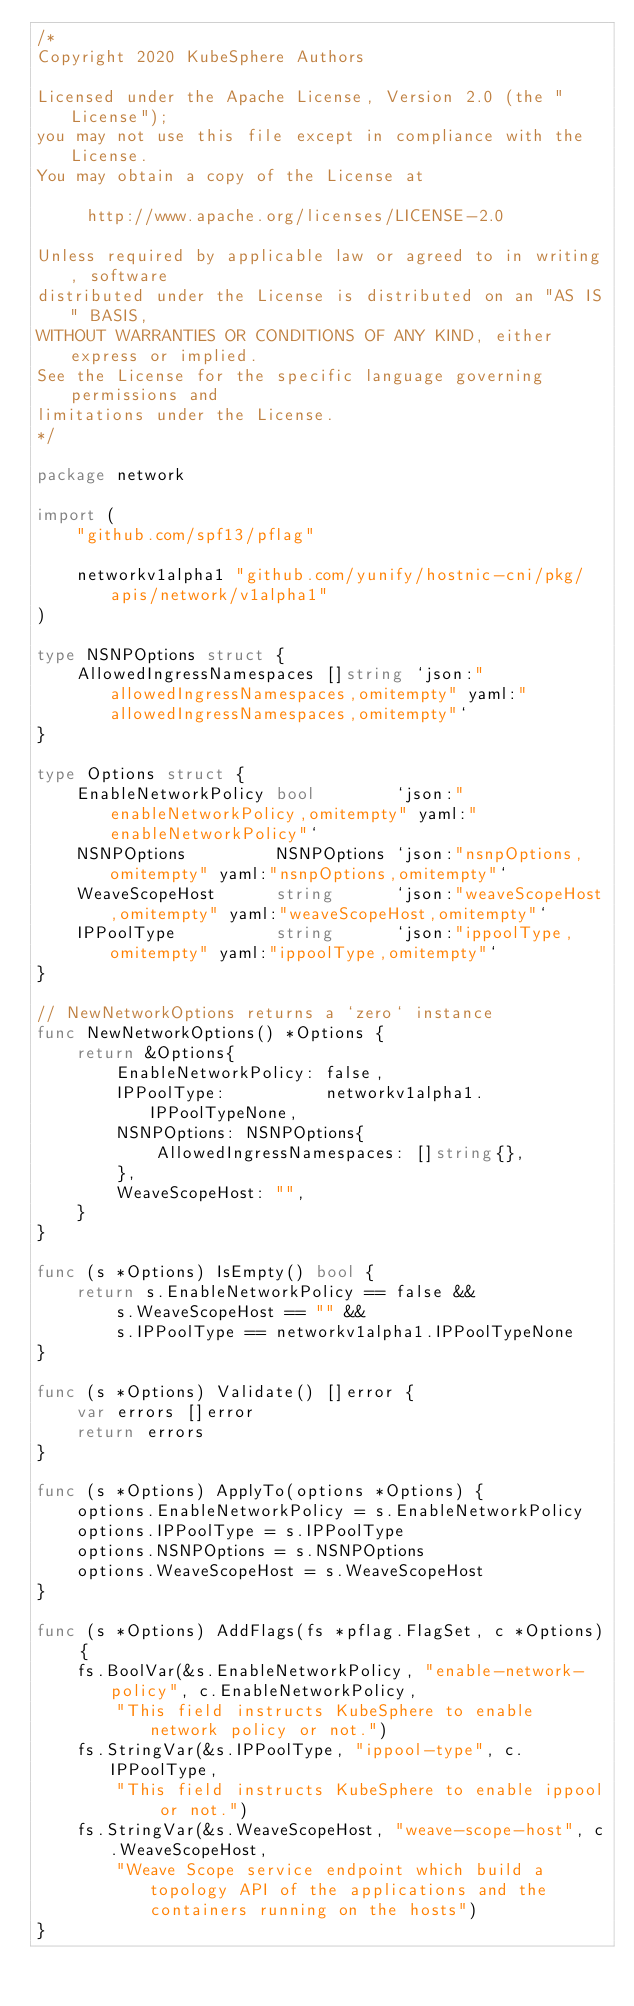Convert code to text. <code><loc_0><loc_0><loc_500><loc_500><_Go_>/*
Copyright 2020 KubeSphere Authors

Licensed under the Apache License, Version 2.0 (the "License");
you may not use this file except in compliance with the License.
You may obtain a copy of the License at

     http://www.apache.org/licenses/LICENSE-2.0

Unless required by applicable law or agreed to in writing, software
distributed under the License is distributed on an "AS IS" BASIS,
WITHOUT WARRANTIES OR CONDITIONS OF ANY KIND, either express or implied.
See the License for the specific language governing permissions and
limitations under the License.
*/

package network

import (
	"github.com/spf13/pflag"

	networkv1alpha1 "github.com/yunify/hostnic-cni/pkg/apis/network/v1alpha1"
)

type NSNPOptions struct {
	AllowedIngressNamespaces []string `json:"allowedIngressNamespaces,omitempty" yaml:"allowedIngressNamespaces,omitempty"`
}

type Options struct {
	EnableNetworkPolicy bool        `json:"enableNetworkPolicy,omitempty" yaml:"enableNetworkPolicy"`
	NSNPOptions         NSNPOptions `json:"nsnpOptions,omitempty" yaml:"nsnpOptions,omitempty"`
	WeaveScopeHost      string      `json:"weaveScopeHost,omitempty" yaml:"weaveScopeHost,omitempty"`
	IPPoolType          string      `json:"ippoolType,omitempty" yaml:"ippoolType,omitempty"`
}

// NewNetworkOptions returns a `zero` instance
func NewNetworkOptions() *Options {
	return &Options{
		EnableNetworkPolicy: false,
		IPPoolType:          networkv1alpha1.IPPoolTypeNone,
		NSNPOptions: NSNPOptions{
			AllowedIngressNamespaces: []string{},
		},
		WeaveScopeHost: "",
	}
}

func (s *Options) IsEmpty() bool {
	return s.EnableNetworkPolicy == false &&
		s.WeaveScopeHost == "" &&
		s.IPPoolType == networkv1alpha1.IPPoolTypeNone
}

func (s *Options) Validate() []error {
	var errors []error
	return errors
}

func (s *Options) ApplyTo(options *Options) {
	options.EnableNetworkPolicy = s.EnableNetworkPolicy
	options.IPPoolType = s.IPPoolType
	options.NSNPOptions = s.NSNPOptions
	options.WeaveScopeHost = s.WeaveScopeHost
}

func (s *Options) AddFlags(fs *pflag.FlagSet, c *Options) {
	fs.BoolVar(&s.EnableNetworkPolicy, "enable-network-policy", c.EnableNetworkPolicy,
		"This field instructs KubeSphere to enable network policy or not.")
	fs.StringVar(&s.IPPoolType, "ippool-type", c.IPPoolType,
		"This field instructs KubeSphere to enable ippool or not.")
	fs.StringVar(&s.WeaveScopeHost, "weave-scope-host", c.WeaveScopeHost,
		"Weave Scope service endpoint which build a topology API of the applications and the containers running on the hosts")
}
</code> 